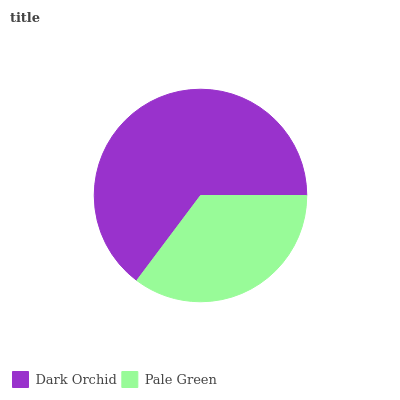Is Pale Green the minimum?
Answer yes or no. Yes. Is Dark Orchid the maximum?
Answer yes or no. Yes. Is Pale Green the maximum?
Answer yes or no. No. Is Dark Orchid greater than Pale Green?
Answer yes or no. Yes. Is Pale Green less than Dark Orchid?
Answer yes or no. Yes. Is Pale Green greater than Dark Orchid?
Answer yes or no. No. Is Dark Orchid less than Pale Green?
Answer yes or no. No. Is Dark Orchid the high median?
Answer yes or no. Yes. Is Pale Green the low median?
Answer yes or no. Yes. Is Pale Green the high median?
Answer yes or no. No. Is Dark Orchid the low median?
Answer yes or no. No. 